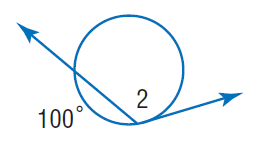Question: Find m \angle 2.
Choices:
A. 100
B. 130
C. 200
D. 300
Answer with the letter. Answer: B 